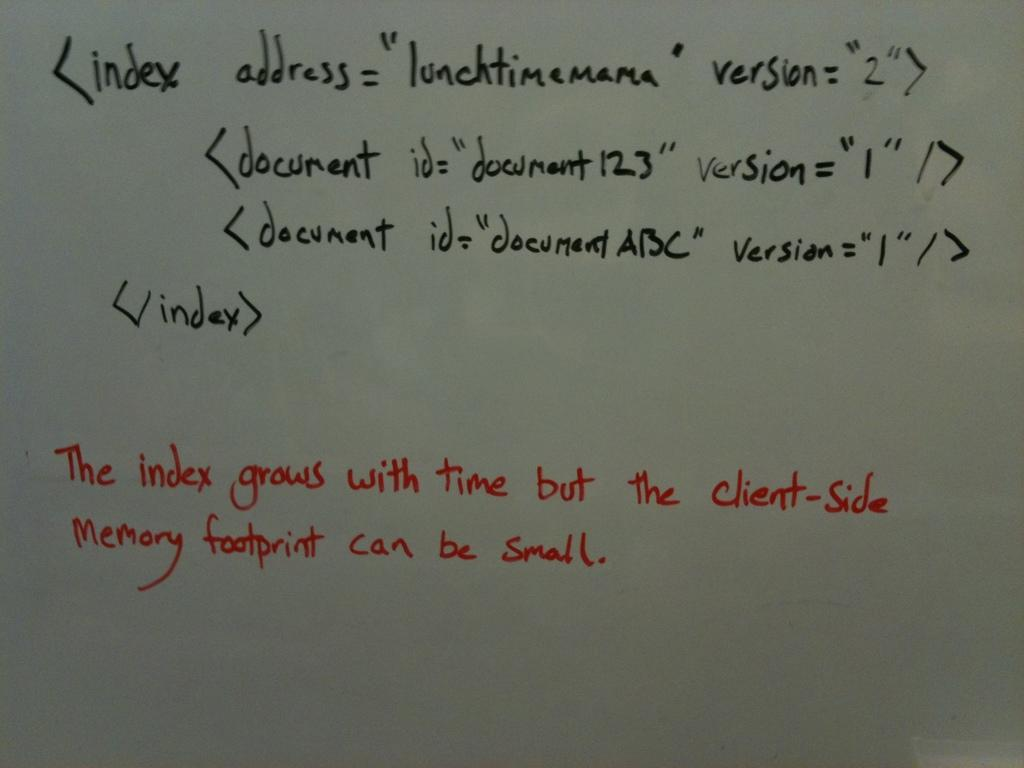<image>
Render a clear and concise summary of the photo. A whiteboard teaching index address and groups with time. 